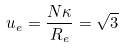<formula> <loc_0><loc_0><loc_500><loc_500>u _ { e } = \frac { N \kappa } { R _ { e } } = \sqrt { 3 }</formula> 